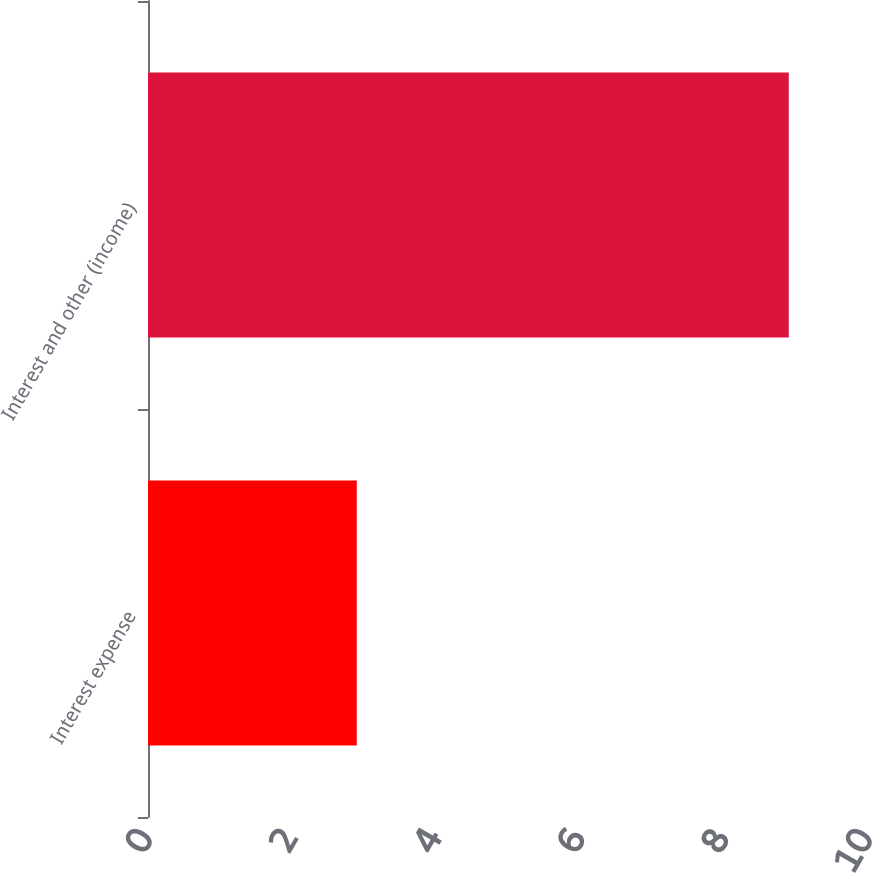Convert chart to OTSL. <chart><loc_0><loc_0><loc_500><loc_500><bar_chart><fcel>Interest expense<fcel>Interest and other (income)<nl><fcel>2.9<fcel>8.9<nl></chart> 